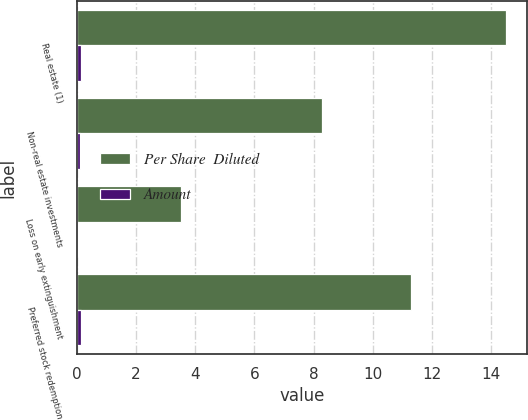<chart> <loc_0><loc_0><loc_500><loc_500><stacked_bar_chart><ecel><fcel>Real estate (1)<fcel>Non-real estate investments<fcel>Loss on early extinguishment<fcel>Preferred stock redemption<nl><fcel>Per Share  Diluted<fcel>14.5<fcel>8.3<fcel>3.5<fcel>11.3<nl><fcel>Amount<fcel>0.15<fcel>0.09<fcel>0.03<fcel>0.12<nl></chart> 